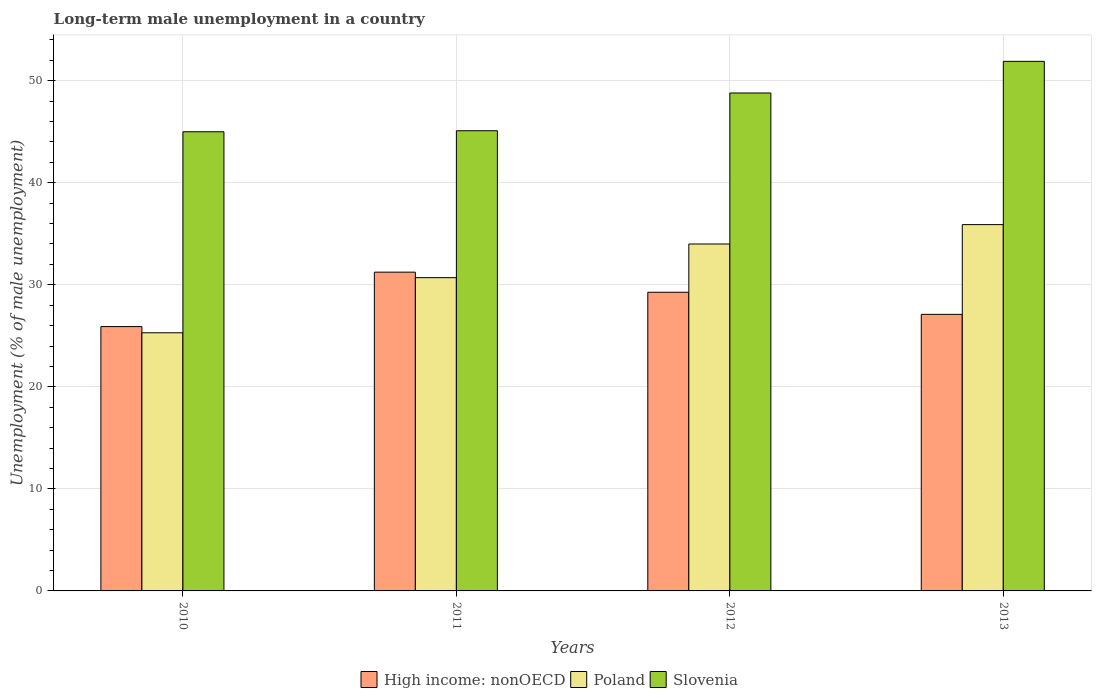How many different coloured bars are there?
Your answer should be compact. 3. How many groups of bars are there?
Your response must be concise. 4. Are the number of bars per tick equal to the number of legend labels?
Offer a terse response. Yes. Are the number of bars on each tick of the X-axis equal?
Provide a short and direct response. Yes. What is the percentage of long-term unemployed male population in High income: nonOECD in 2011?
Provide a short and direct response. 31.24. Across all years, what is the maximum percentage of long-term unemployed male population in Slovenia?
Keep it short and to the point. 51.9. Across all years, what is the minimum percentage of long-term unemployed male population in High income: nonOECD?
Your response must be concise. 25.91. In which year was the percentage of long-term unemployed male population in High income: nonOECD maximum?
Ensure brevity in your answer.  2011. In which year was the percentage of long-term unemployed male population in Poland minimum?
Offer a terse response. 2010. What is the total percentage of long-term unemployed male population in High income: nonOECD in the graph?
Offer a terse response. 113.52. What is the difference between the percentage of long-term unemployed male population in High income: nonOECD in 2011 and that in 2012?
Your answer should be compact. 1.97. What is the difference between the percentage of long-term unemployed male population in High income: nonOECD in 2011 and the percentage of long-term unemployed male population in Poland in 2010?
Your answer should be very brief. 5.94. What is the average percentage of long-term unemployed male population in High income: nonOECD per year?
Offer a very short reply. 28.38. In how many years, is the percentage of long-term unemployed male population in High income: nonOECD greater than 2 %?
Make the answer very short. 4. What is the ratio of the percentage of long-term unemployed male population in Slovenia in 2010 to that in 2013?
Give a very brief answer. 0.87. Is the difference between the percentage of long-term unemployed male population in Slovenia in 2010 and 2011 greater than the difference between the percentage of long-term unemployed male population in Poland in 2010 and 2011?
Provide a short and direct response. Yes. What is the difference between the highest and the second highest percentage of long-term unemployed male population in Slovenia?
Offer a terse response. 3.1. What is the difference between the highest and the lowest percentage of long-term unemployed male population in Poland?
Keep it short and to the point. 10.6. In how many years, is the percentage of long-term unemployed male population in Poland greater than the average percentage of long-term unemployed male population in Poland taken over all years?
Provide a short and direct response. 2. Is the sum of the percentage of long-term unemployed male population in Slovenia in 2010 and 2012 greater than the maximum percentage of long-term unemployed male population in High income: nonOECD across all years?
Offer a very short reply. Yes. What does the 3rd bar from the right in 2010 represents?
Offer a very short reply. High income: nonOECD. Are all the bars in the graph horizontal?
Your answer should be compact. No. How many years are there in the graph?
Your answer should be compact. 4. Are the values on the major ticks of Y-axis written in scientific E-notation?
Your answer should be very brief. No. Does the graph contain any zero values?
Ensure brevity in your answer.  No. Does the graph contain grids?
Provide a succinct answer. Yes. How are the legend labels stacked?
Offer a terse response. Horizontal. What is the title of the graph?
Provide a succinct answer. Long-term male unemployment in a country. Does "High income: nonOECD" appear as one of the legend labels in the graph?
Your response must be concise. Yes. What is the label or title of the X-axis?
Make the answer very short. Years. What is the label or title of the Y-axis?
Offer a very short reply. Unemployment (% of male unemployment). What is the Unemployment (% of male unemployment) in High income: nonOECD in 2010?
Keep it short and to the point. 25.91. What is the Unemployment (% of male unemployment) of Poland in 2010?
Your answer should be compact. 25.3. What is the Unemployment (% of male unemployment) of High income: nonOECD in 2011?
Provide a succinct answer. 31.24. What is the Unemployment (% of male unemployment) in Poland in 2011?
Your answer should be compact. 30.7. What is the Unemployment (% of male unemployment) in Slovenia in 2011?
Ensure brevity in your answer.  45.1. What is the Unemployment (% of male unemployment) in High income: nonOECD in 2012?
Give a very brief answer. 29.27. What is the Unemployment (% of male unemployment) of Slovenia in 2012?
Make the answer very short. 48.8. What is the Unemployment (% of male unemployment) in High income: nonOECD in 2013?
Your answer should be very brief. 27.11. What is the Unemployment (% of male unemployment) in Poland in 2013?
Keep it short and to the point. 35.9. What is the Unemployment (% of male unemployment) of Slovenia in 2013?
Keep it short and to the point. 51.9. Across all years, what is the maximum Unemployment (% of male unemployment) of High income: nonOECD?
Offer a very short reply. 31.24. Across all years, what is the maximum Unemployment (% of male unemployment) of Poland?
Provide a succinct answer. 35.9. Across all years, what is the maximum Unemployment (% of male unemployment) in Slovenia?
Offer a very short reply. 51.9. Across all years, what is the minimum Unemployment (% of male unemployment) in High income: nonOECD?
Provide a succinct answer. 25.91. Across all years, what is the minimum Unemployment (% of male unemployment) in Poland?
Your answer should be compact. 25.3. Across all years, what is the minimum Unemployment (% of male unemployment) of Slovenia?
Provide a short and direct response. 45. What is the total Unemployment (% of male unemployment) of High income: nonOECD in the graph?
Your answer should be compact. 113.52. What is the total Unemployment (% of male unemployment) in Poland in the graph?
Give a very brief answer. 125.9. What is the total Unemployment (% of male unemployment) of Slovenia in the graph?
Your answer should be compact. 190.8. What is the difference between the Unemployment (% of male unemployment) in High income: nonOECD in 2010 and that in 2011?
Keep it short and to the point. -5.34. What is the difference between the Unemployment (% of male unemployment) of Slovenia in 2010 and that in 2011?
Give a very brief answer. -0.1. What is the difference between the Unemployment (% of male unemployment) of High income: nonOECD in 2010 and that in 2012?
Give a very brief answer. -3.36. What is the difference between the Unemployment (% of male unemployment) of Poland in 2010 and that in 2012?
Provide a succinct answer. -8.7. What is the difference between the Unemployment (% of male unemployment) in High income: nonOECD in 2010 and that in 2013?
Your response must be concise. -1.2. What is the difference between the Unemployment (% of male unemployment) in Poland in 2010 and that in 2013?
Your answer should be very brief. -10.6. What is the difference between the Unemployment (% of male unemployment) of Slovenia in 2010 and that in 2013?
Ensure brevity in your answer.  -6.9. What is the difference between the Unemployment (% of male unemployment) in High income: nonOECD in 2011 and that in 2012?
Provide a short and direct response. 1.97. What is the difference between the Unemployment (% of male unemployment) of Poland in 2011 and that in 2012?
Ensure brevity in your answer.  -3.3. What is the difference between the Unemployment (% of male unemployment) of Slovenia in 2011 and that in 2012?
Ensure brevity in your answer.  -3.7. What is the difference between the Unemployment (% of male unemployment) of High income: nonOECD in 2011 and that in 2013?
Your answer should be compact. 4.14. What is the difference between the Unemployment (% of male unemployment) of Poland in 2011 and that in 2013?
Your answer should be very brief. -5.2. What is the difference between the Unemployment (% of male unemployment) of High income: nonOECD in 2012 and that in 2013?
Offer a very short reply. 2.16. What is the difference between the Unemployment (% of male unemployment) in High income: nonOECD in 2010 and the Unemployment (% of male unemployment) in Poland in 2011?
Your answer should be compact. -4.79. What is the difference between the Unemployment (% of male unemployment) of High income: nonOECD in 2010 and the Unemployment (% of male unemployment) of Slovenia in 2011?
Offer a terse response. -19.19. What is the difference between the Unemployment (% of male unemployment) in Poland in 2010 and the Unemployment (% of male unemployment) in Slovenia in 2011?
Offer a terse response. -19.8. What is the difference between the Unemployment (% of male unemployment) in High income: nonOECD in 2010 and the Unemployment (% of male unemployment) in Poland in 2012?
Give a very brief answer. -8.09. What is the difference between the Unemployment (% of male unemployment) in High income: nonOECD in 2010 and the Unemployment (% of male unemployment) in Slovenia in 2012?
Offer a very short reply. -22.89. What is the difference between the Unemployment (% of male unemployment) in Poland in 2010 and the Unemployment (% of male unemployment) in Slovenia in 2012?
Your answer should be very brief. -23.5. What is the difference between the Unemployment (% of male unemployment) of High income: nonOECD in 2010 and the Unemployment (% of male unemployment) of Poland in 2013?
Your answer should be very brief. -9.99. What is the difference between the Unemployment (% of male unemployment) of High income: nonOECD in 2010 and the Unemployment (% of male unemployment) of Slovenia in 2013?
Your response must be concise. -25.99. What is the difference between the Unemployment (% of male unemployment) of Poland in 2010 and the Unemployment (% of male unemployment) of Slovenia in 2013?
Your answer should be very brief. -26.6. What is the difference between the Unemployment (% of male unemployment) of High income: nonOECD in 2011 and the Unemployment (% of male unemployment) of Poland in 2012?
Keep it short and to the point. -2.76. What is the difference between the Unemployment (% of male unemployment) of High income: nonOECD in 2011 and the Unemployment (% of male unemployment) of Slovenia in 2012?
Your response must be concise. -17.56. What is the difference between the Unemployment (% of male unemployment) of Poland in 2011 and the Unemployment (% of male unemployment) of Slovenia in 2012?
Your answer should be very brief. -18.1. What is the difference between the Unemployment (% of male unemployment) in High income: nonOECD in 2011 and the Unemployment (% of male unemployment) in Poland in 2013?
Your response must be concise. -4.66. What is the difference between the Unemployment (% of male unemployment) in High income: nonOECD in 2011 and the Unemployment (% of male unemployment) in Slovenia in 2013?
Keep it short and to the point. -20.66. What is the difference between the Unemployment (% of male unemployment) of Poland in 2011 and the Unemployment (% of male unemployment) of Slovenia in 2013?
Make the answer very short. -21.2. What is the difference between the Unemployment (% of male unemployment) in High income: nonOECD in 2012 and the Unemployment (% of male unemployment) in Poland in 2013?
Your answer should be very brief. -6.63. What is the difference between the Unemployment (% of male unemployment) of High income: nonOECD in 2012 and the Unemployment (% of male unemployment) of Slovenia in 2013?
Offer a terse response. -22.63. What is the difference between the Unemployment (% of male unemployment) in Poland in 2012 and the Unemployment (% of male unemployment) in Slovenia in 2013?
Keep it short and to the point. -17.9. What is the average Unemployment (% of male unemployment) in High income: nonOECD per year?
Provide a succinct answer. 28.38. What is the average Unemployment (% of male unemployment) of Poland per year?
Ensure brevity in your answer.  31.48. What is the average Unemployment (% of male unemployment) in Slovenia per year?
Ensure brevity in your answer.  47.7. In the year 2010, what is the difference between the Unemployment (% of male unemployment) of High income: nonOECD and Unemployment (% of male unemployment) of Poland?
Provide a short and direct response. 0.61. In the year 2010, what is the difference between the Unemployment (% of male unemployment) of High income: nonOECD and Unemployment (% of male unemployment) of Slovenia?
Provide a succinct answer. -19.09. In the year 2010, what is the difference between the Unemployment (% of male unemployment) in Poland and Unemployment (% of male unemployment) in Slovenia?
Make the answer very short. -19.7. In the year 2011, what is the difference between the Unemployment (% of male unemployment) in High income: nonOECD and Unemployment (% of male unemployment) in Poland?
Your answer should be very brief. 0.54. In the year 2011, what is the difference between the Unemployment (% of male unemployment) of High income: nonOECD and Unemployment (% of male unemployment) of Slovenia?
Provide a succinct answer. -13.86. In the year 2011, what is the difference between the Unemployment (% of male unemployment) of Poland and Unemployment (% of male unemployment) of Slovenia?
Ensure brevity in your answer.  -14.4. In the year 2012, what is the difference between the Unemployment (% of male unemployment) in High income: nonOECD and Unemployment (% of male unemployment) in Poland?
Offer a very short reply. -4.73. In the year 2012, what is the difference between the Unemployment (% of male unemployment) of High income: nonOECD and Unemployment (% of male unemployment) of Slovenia?
Offer a very short reply. -19.53. In the year 2012, what is the difference between the Unemployment (% of male unemployment) of Poland and Unemployment (% of male unemployment) of Slovenia?
Offer a very short reply. -14.8. In the year 2013, what is the difference between the Unemployment (% of male unemployment) of High income: nonOECD and Unemployment (% of male unemployment) of Poland?
Your answer should be compact. -8.79. In the year 2013, what is the difference between the Unemployment (% of male unemployment) in High income: nonOECD and Unemployment (% of male unemployment) in Slovenia?
Your response must be concise. -24.79. In the year 2013, what is the difference between the Unemployment (% of male unemployment) in Poland and Unemployment (% of male unemployment) in Slovenia?
Your response must be concise. -16. What is the ratio of the Unemployment (% of male unemployment) of High income: nonOECD in 2010 to that in 2011?
Make the answer very short. 0.83. What is the ratio of the Unemployment (% of male unemployment) in Poland in 2010 to that in 2011?
Ensure brevity in your answer.  0.82. What is the ratio of the Unemployment (% of male unemployment) of High income: nonOECD in 2010 to that in 2012?
Keep it short and to the point. 0.89. What is the ratio of the Unemployment (% of male unemployment) of Poland in 2010 to that in 2012?
Offer a very short reply. 0.74. What is the ratio of the Unemployment (% of male unemployment) in Slovenia in 2010 to that in 2012?
Provide a succinct answer. 0.92. What is the ratio of the Unemployment (% of male unemployment) in High income: nonOECD in 2010 to that in 2013?
Offer a terse response. 0.96. What is the ratio of the Unemployment (% of male unemployment) in Poland in 2010 to that in 2013?
Offer a very short reply. 0.7. What is the ratio of the Unemployment (% of male unemployment) in Slovenia in 2010 to that in 2013?
Your response must be concise. 0.87. What is the ratio of the Unemployment (% of male unemployment) of High income: nonOECD in 2011 to that in 2012?
Your response must be concise. 1.07. What is the ratio of the Unemployment (% of male unemployment) of Poland in 2011 to that in 2012?
Keep it short and to the point. 0.9. What is the ratio of the Unemployment (% of male unemployment) of Slovenia in 2011 to that in 2012?
Your answer should be very brief. 0.92. What is the ratio of the Unemployment (% of male unemployment) of High income: nonOECD in 2011 to that in 2013?
Your answer should be very brief. 1.15. What is the ratio of the Unemployment (% of male unemployment) of Poland in 2011 to that in 2013?
Provide a short and direct response. 0.86. What is the ratio of the Unemployment (% of male unemployment) of Slovenia in 2011 to that in 2013?
Your answer should be very brief. 0.87. What is the ratio of the Unemployment (% of male unemployment) in High income: nonOECD in 2012 to that in 2013?
Provide a succinct answer. 1.08. What is the ratio of the Unemployment (% of male unemployment) of Poland in 2012 to that in 2013?
Provide a short and direct response. 0.95. What is the ratio of the Unemployment (% of male unemployment) of Slovenia in 2012 to that in 2013?
Offer a very short reply. 0.94. What is the difference between the highest and the second highest Unemployment (% of male unemployment) of High income: nonOECD?
Provide a short and direct response. 1.97. What is the difference between the highest and the second highest Unemployment (% of male unemployment) in Slovenia?
Provide a succinct answer. 3.1. What is the difference between the highest and the lowest Unemployment (% of male unemployment) of High income: nonOECD?
Make the answer very short. 5.34. 